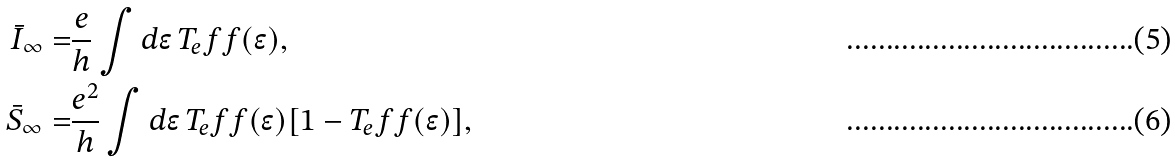Convert formula to latex. <formula><loc_0><loc_0><loc_500><loc_500>\bar { I } _ { \infty } = & \frac { e } { h } \int d \epsilon \, T _ { e } f f ( \epsilon ) , \\ \bar { S } _ { \infty } = & \frac { e ^ { 2 } } { h } \int d \epsilon \, T _ { e } f f ( \epsilon ) [ 1 - T _ { e } f f ( \epsilon ) ] ,</formula> 